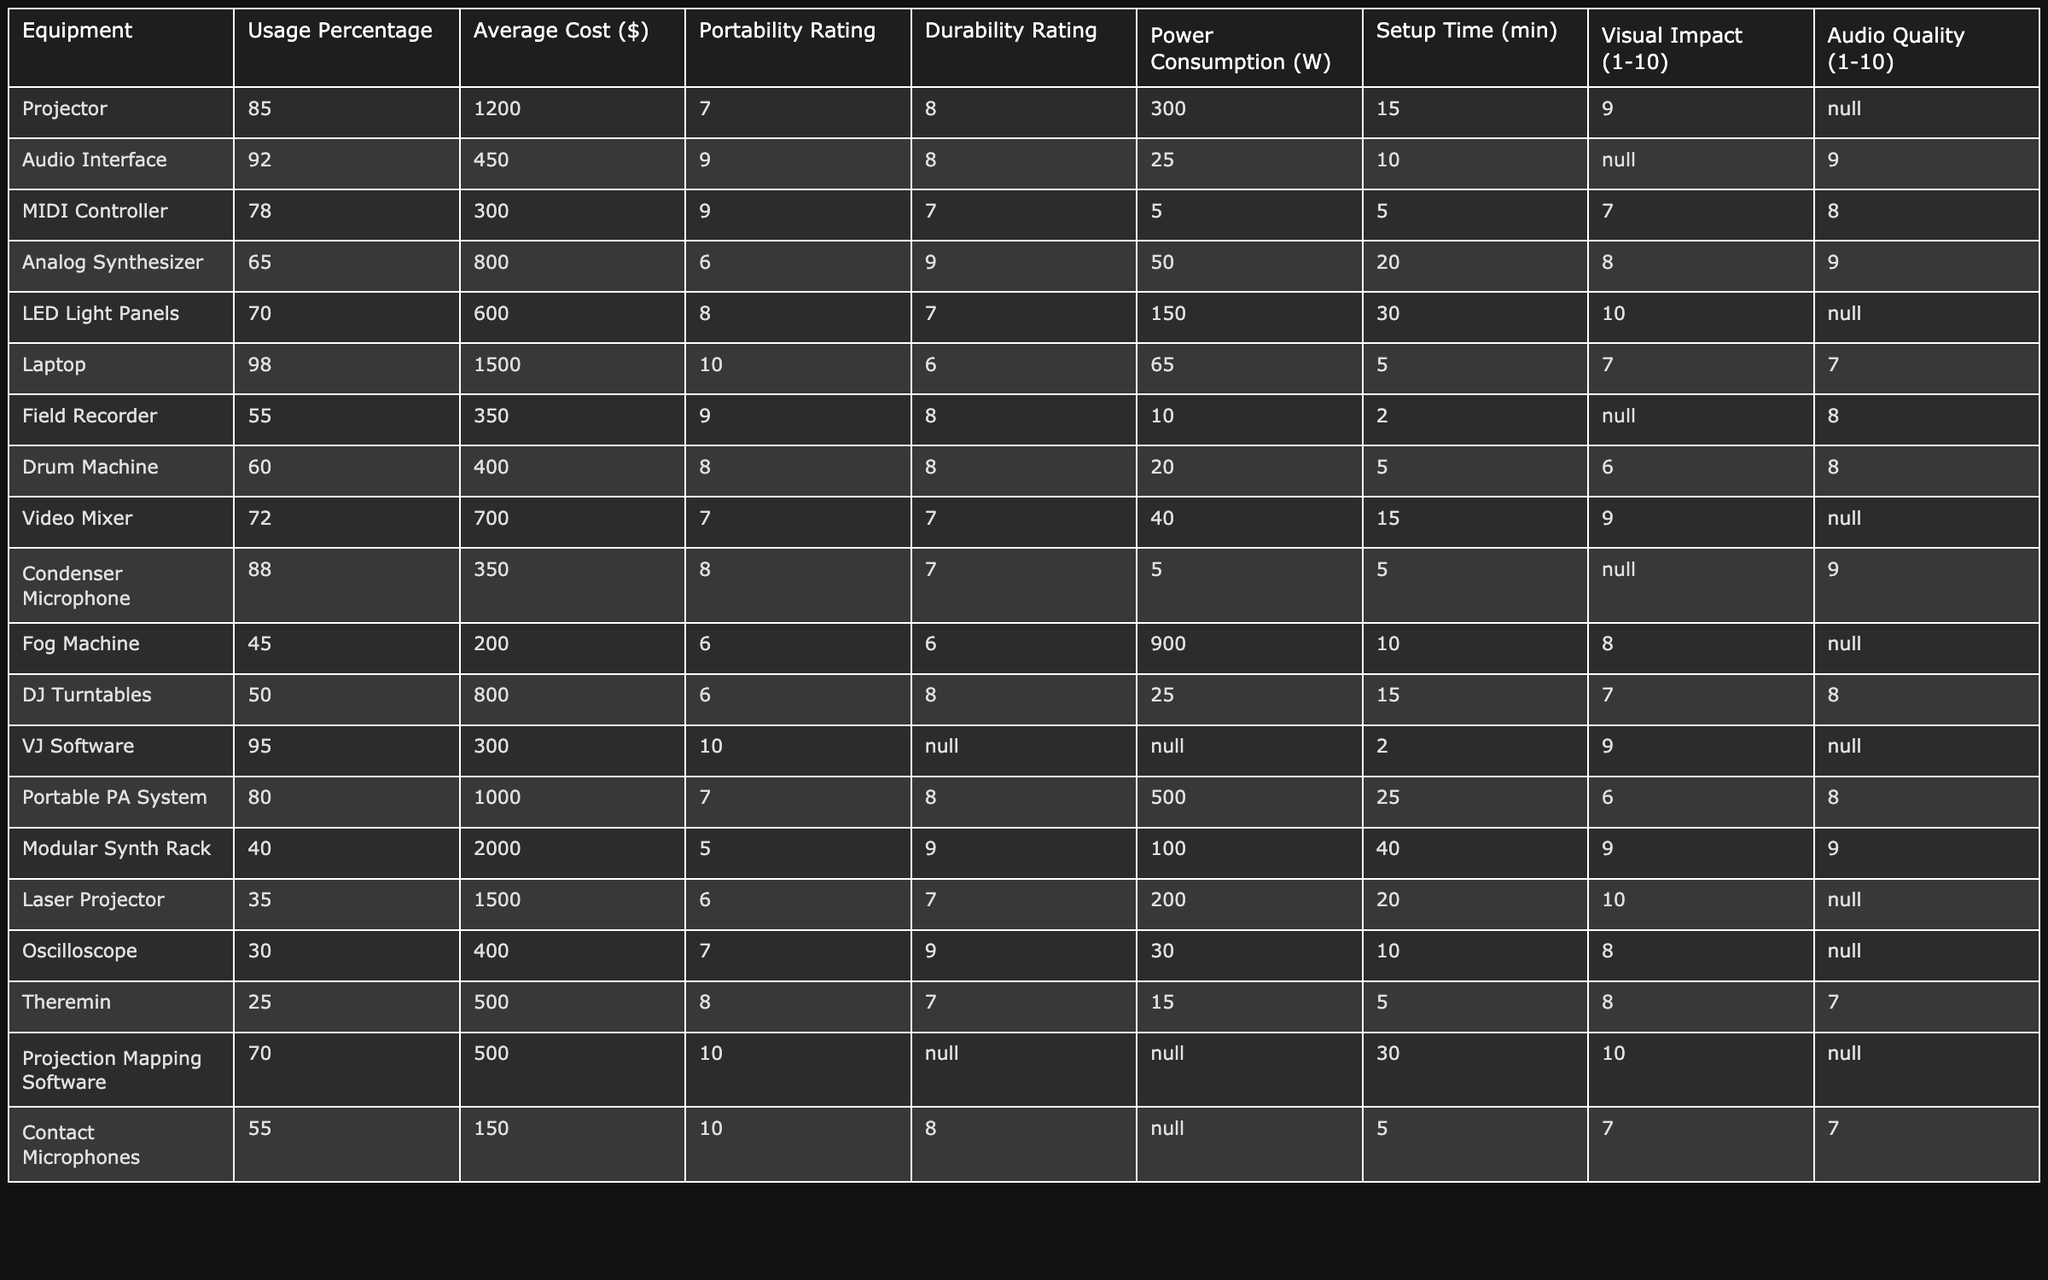What equipment has the highest usage percentage for audiovisual performances? The highest usage percentage is found in the Laptop at 98%.
Answer: Laptop What is the average cost of all the equipment listed in the table? To find the average cost, we sum all the Average Costs: (1200 + 450 + 300 + 800 + 600 + 1500 + 350 + 400 + 700 + 350 + 200 + 800 + 300 + 1000 + 2000 + 1500 + 400 + 500 + 150) = 13000. Dividing by the number of items (17), we find the average is 13000 / 17 ≈ 764.71.
Answer: 764.71 Is the power consumption of the Portable PA System higher than the Audio Interface? The Portable PA System consumes 500W while the Audio Interface consumes only 25W, thus the statement is true.
Answer: True Which equipment has the lowest portability rating? The Modular Synth Rack has the lowest portability rating at 5.
Answer: Modular Synth Rack How many types of equipment have a visual impact rating of 10? There are three types of equipment with a visual impact rating of 10: LED Light Panels, VJ Software, and Projection Mapping Software.
Answer: 3 What is the difference in power consumption between the Fog Machine and the Analog Synthesizer? The Fog Machine uses 900W while the Analog Synthesizer uses 50W. The difference in power consumption is 900W - 50W = 850W.
Answer: 850W Which equipment has both a high usage percentage and a low average cost? The Audio Interface has a high usage percentage at 92% and a relatively low average cost of $450.
Answer: Audio Interface What is the total setup time for all equipment that has a durability rating of 8 or more? We sum the setup times of the equipment with a durability rating of 8 or higher: Audio Interface (10) + Analog Synthesizer (20) + Condenser Microphone (5) + VJ Software (2) + Portable PA System (25) + Field Recorder (2) + Contact Microphones (5) = 69 minutes.
Answer: 69 minutes Is it true that all equipment with a visual impact above 9 also has an audio quality rating of 9? The Fog Machine and Laser Projector have a visual impact above 9 but do not have audio quality ratings listed, so the statement is false.
Answer: False Which equipment requires the longest setup time? The Modular Synth Rack requires the longest setup time of 40 minutes.
Answer: Modular Synth Rack 